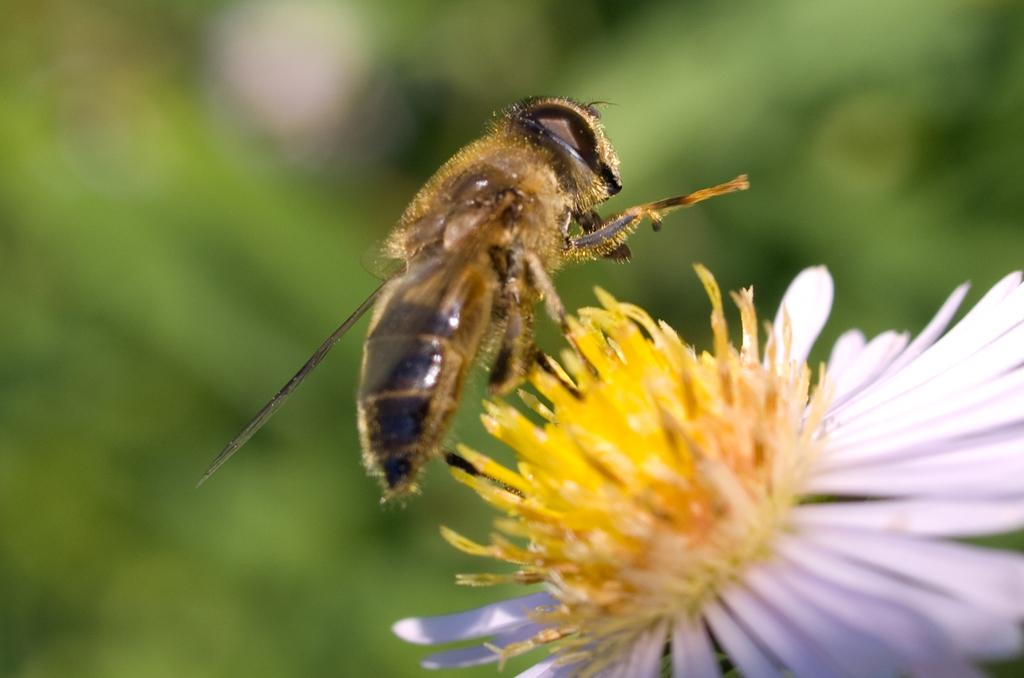What is the main subject of the image? The main subject of the image is a honey bee. Where is the honey bee located in the image? The honey bee is on a flower. What is the position of the flower in the image? The flower is in the center of the image. What type of knee can be seen in the image? There is no knee present in the image; it features a honey bee on a flower. 